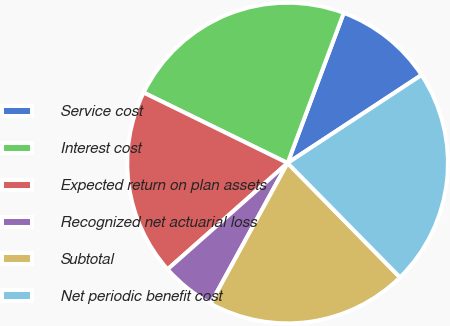Convert chart to OTSL. <chart><loc_0><loc_0><loc_500><loc_500><pie_chart><fcel>Service cost<fcel>Interest cost<fcel>Expected return on plan assets<fcel>Recognized net actuarial loss<fcel>Subtotal<fcel>Net periodic benefit cost<nl><fcel>10.05%<fcel>23.45%<fcel>18.78%<fcel>5.49%<fcel>20.34%<fcel>21.89%<nl></chart> 